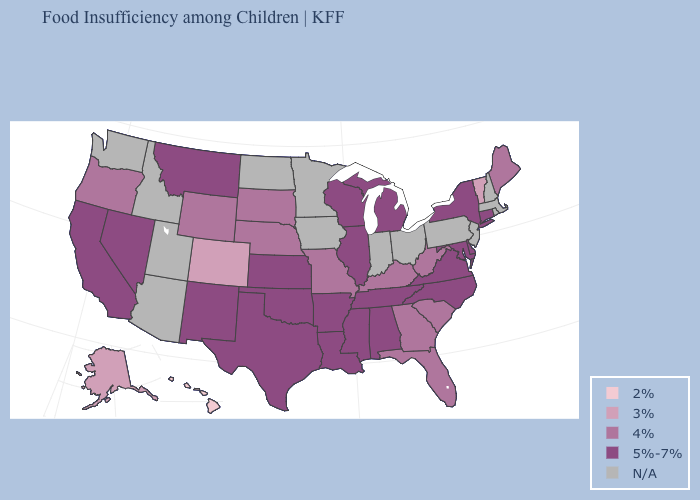Which states hav the highest value in the South?
Answer briefly. Alabama, Arkansas, Delaware, Louisiana, Maryland, Mississippi, North Carolina, Oklahoma, Tennessee, Texas, Virginia. Name the states that have a value in the range 3%?
Concise answer only. Alaska, Colorado, Vermont. Among the states that border Florida , does Georgia have the highest value?
Give a very brief answer. No. Does Wisconsin have the lowest value in the MidWest?
Quick response, please. No. Which states have the lowest value in the USA?
Give a very brief answer. Hawaii. Is the legend a continuous bar?
Write a very short answer. No. How many symbols are there in the legend?
Concise answer only. 5. What is the lowest value in states that border Delaware?
Concise answer only. 5%-7%. Name the states that have a value in the range 3%?
Answer briefly. Alaska, Colorado, Vermont. Among the states that border Kentucky , which have the lowest value?
Give a very brief answer. Missouri, West Virginia. What is the value of Missouri?
Keep it brief. 4%. Among the states that border Texas , which have the lowest value?
Give a very brief answer. Arkansas, Louisiana, New Mexico, Oklahoma. What is the lowest value in the USA?
Concise answer only. 2%. What is the value of Ohio?
Keep it brief. N/A. 